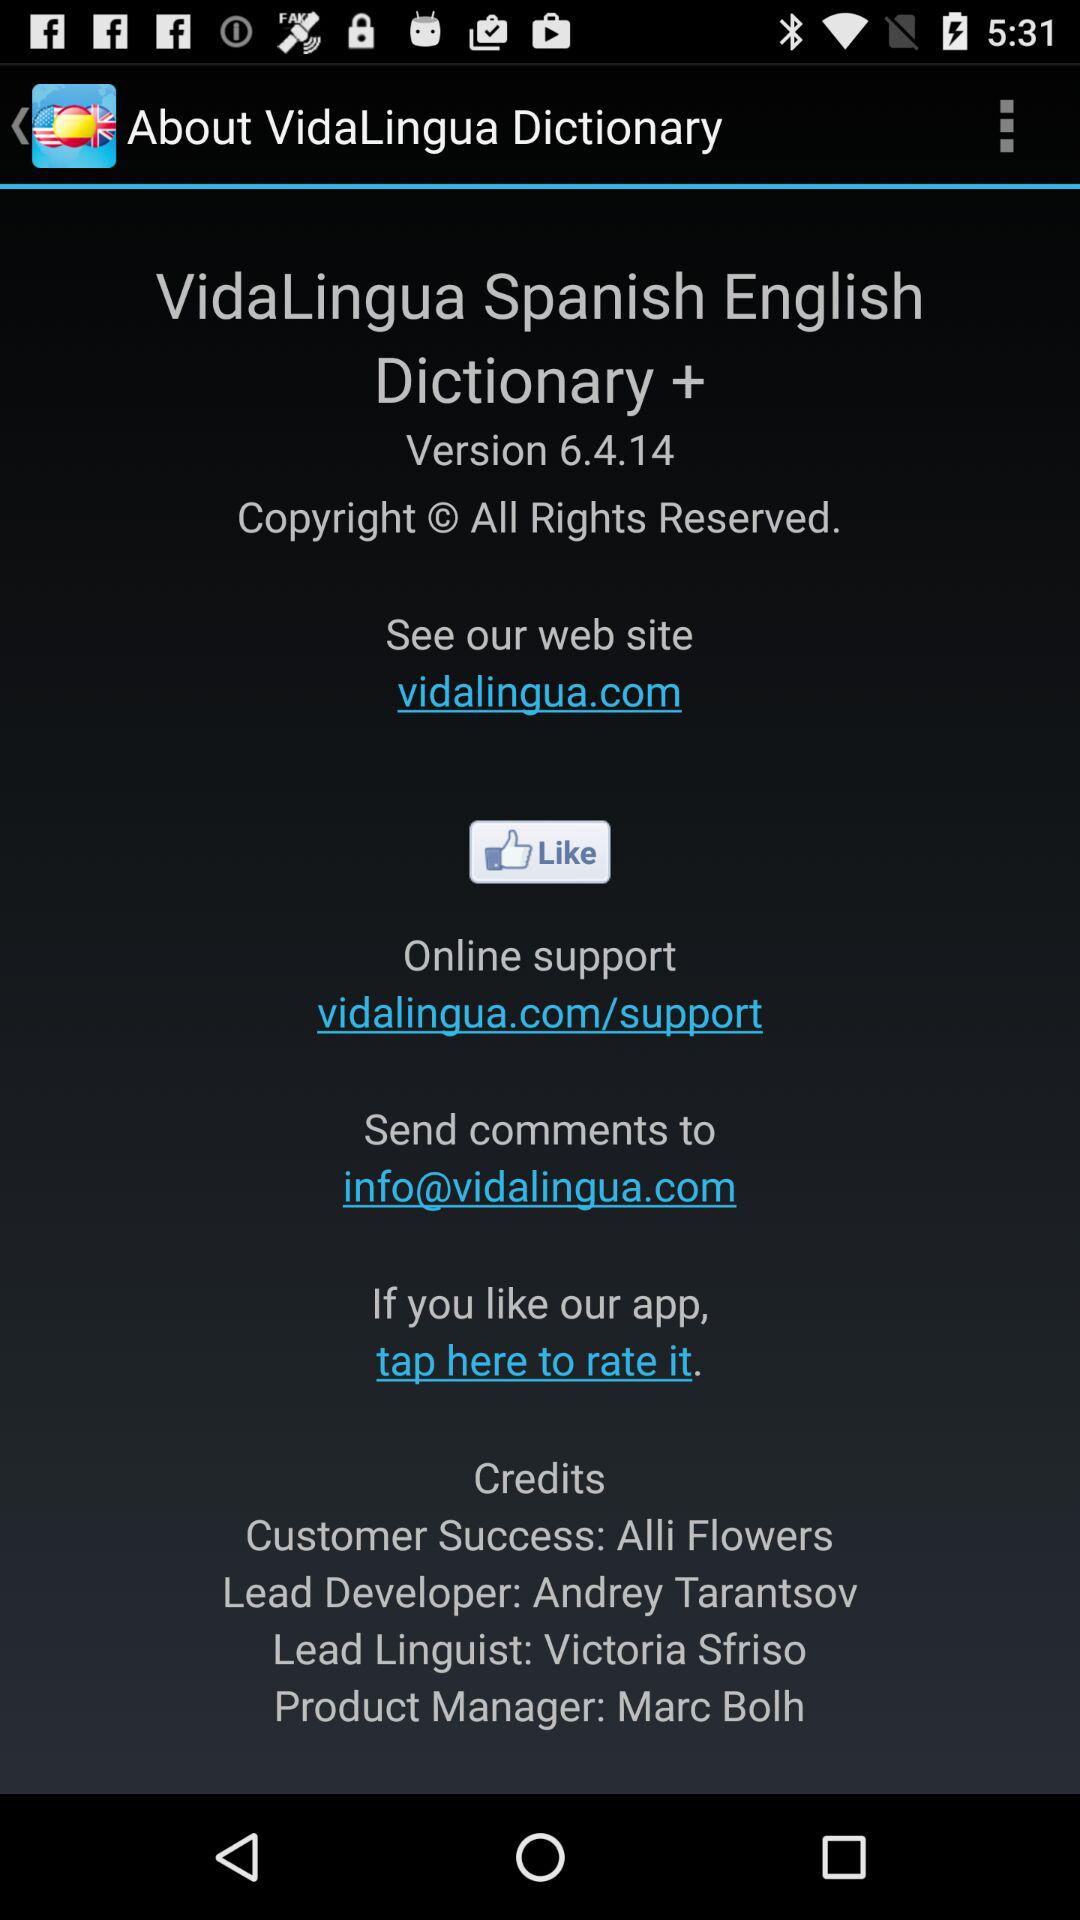Who is the developer? The developer is Andrey Tarantsov. 